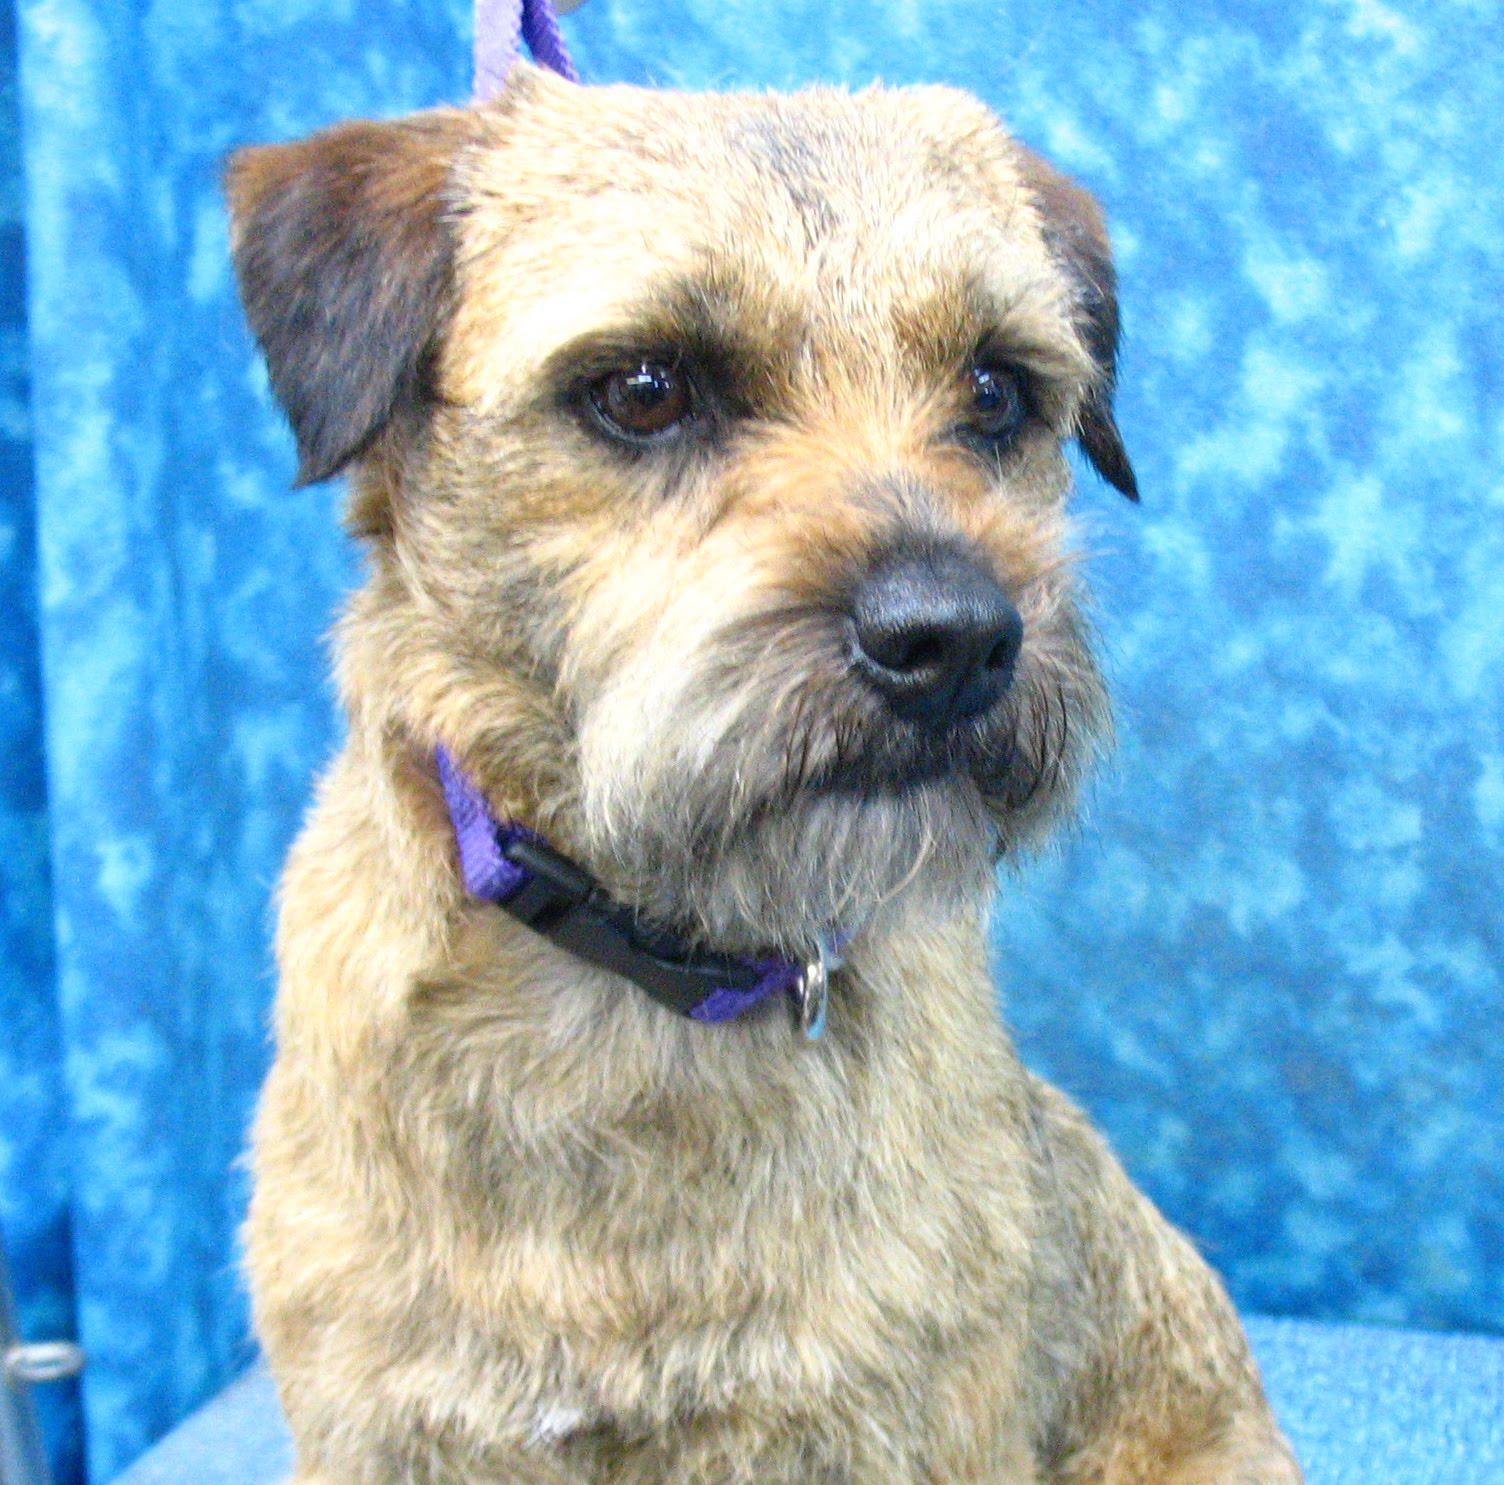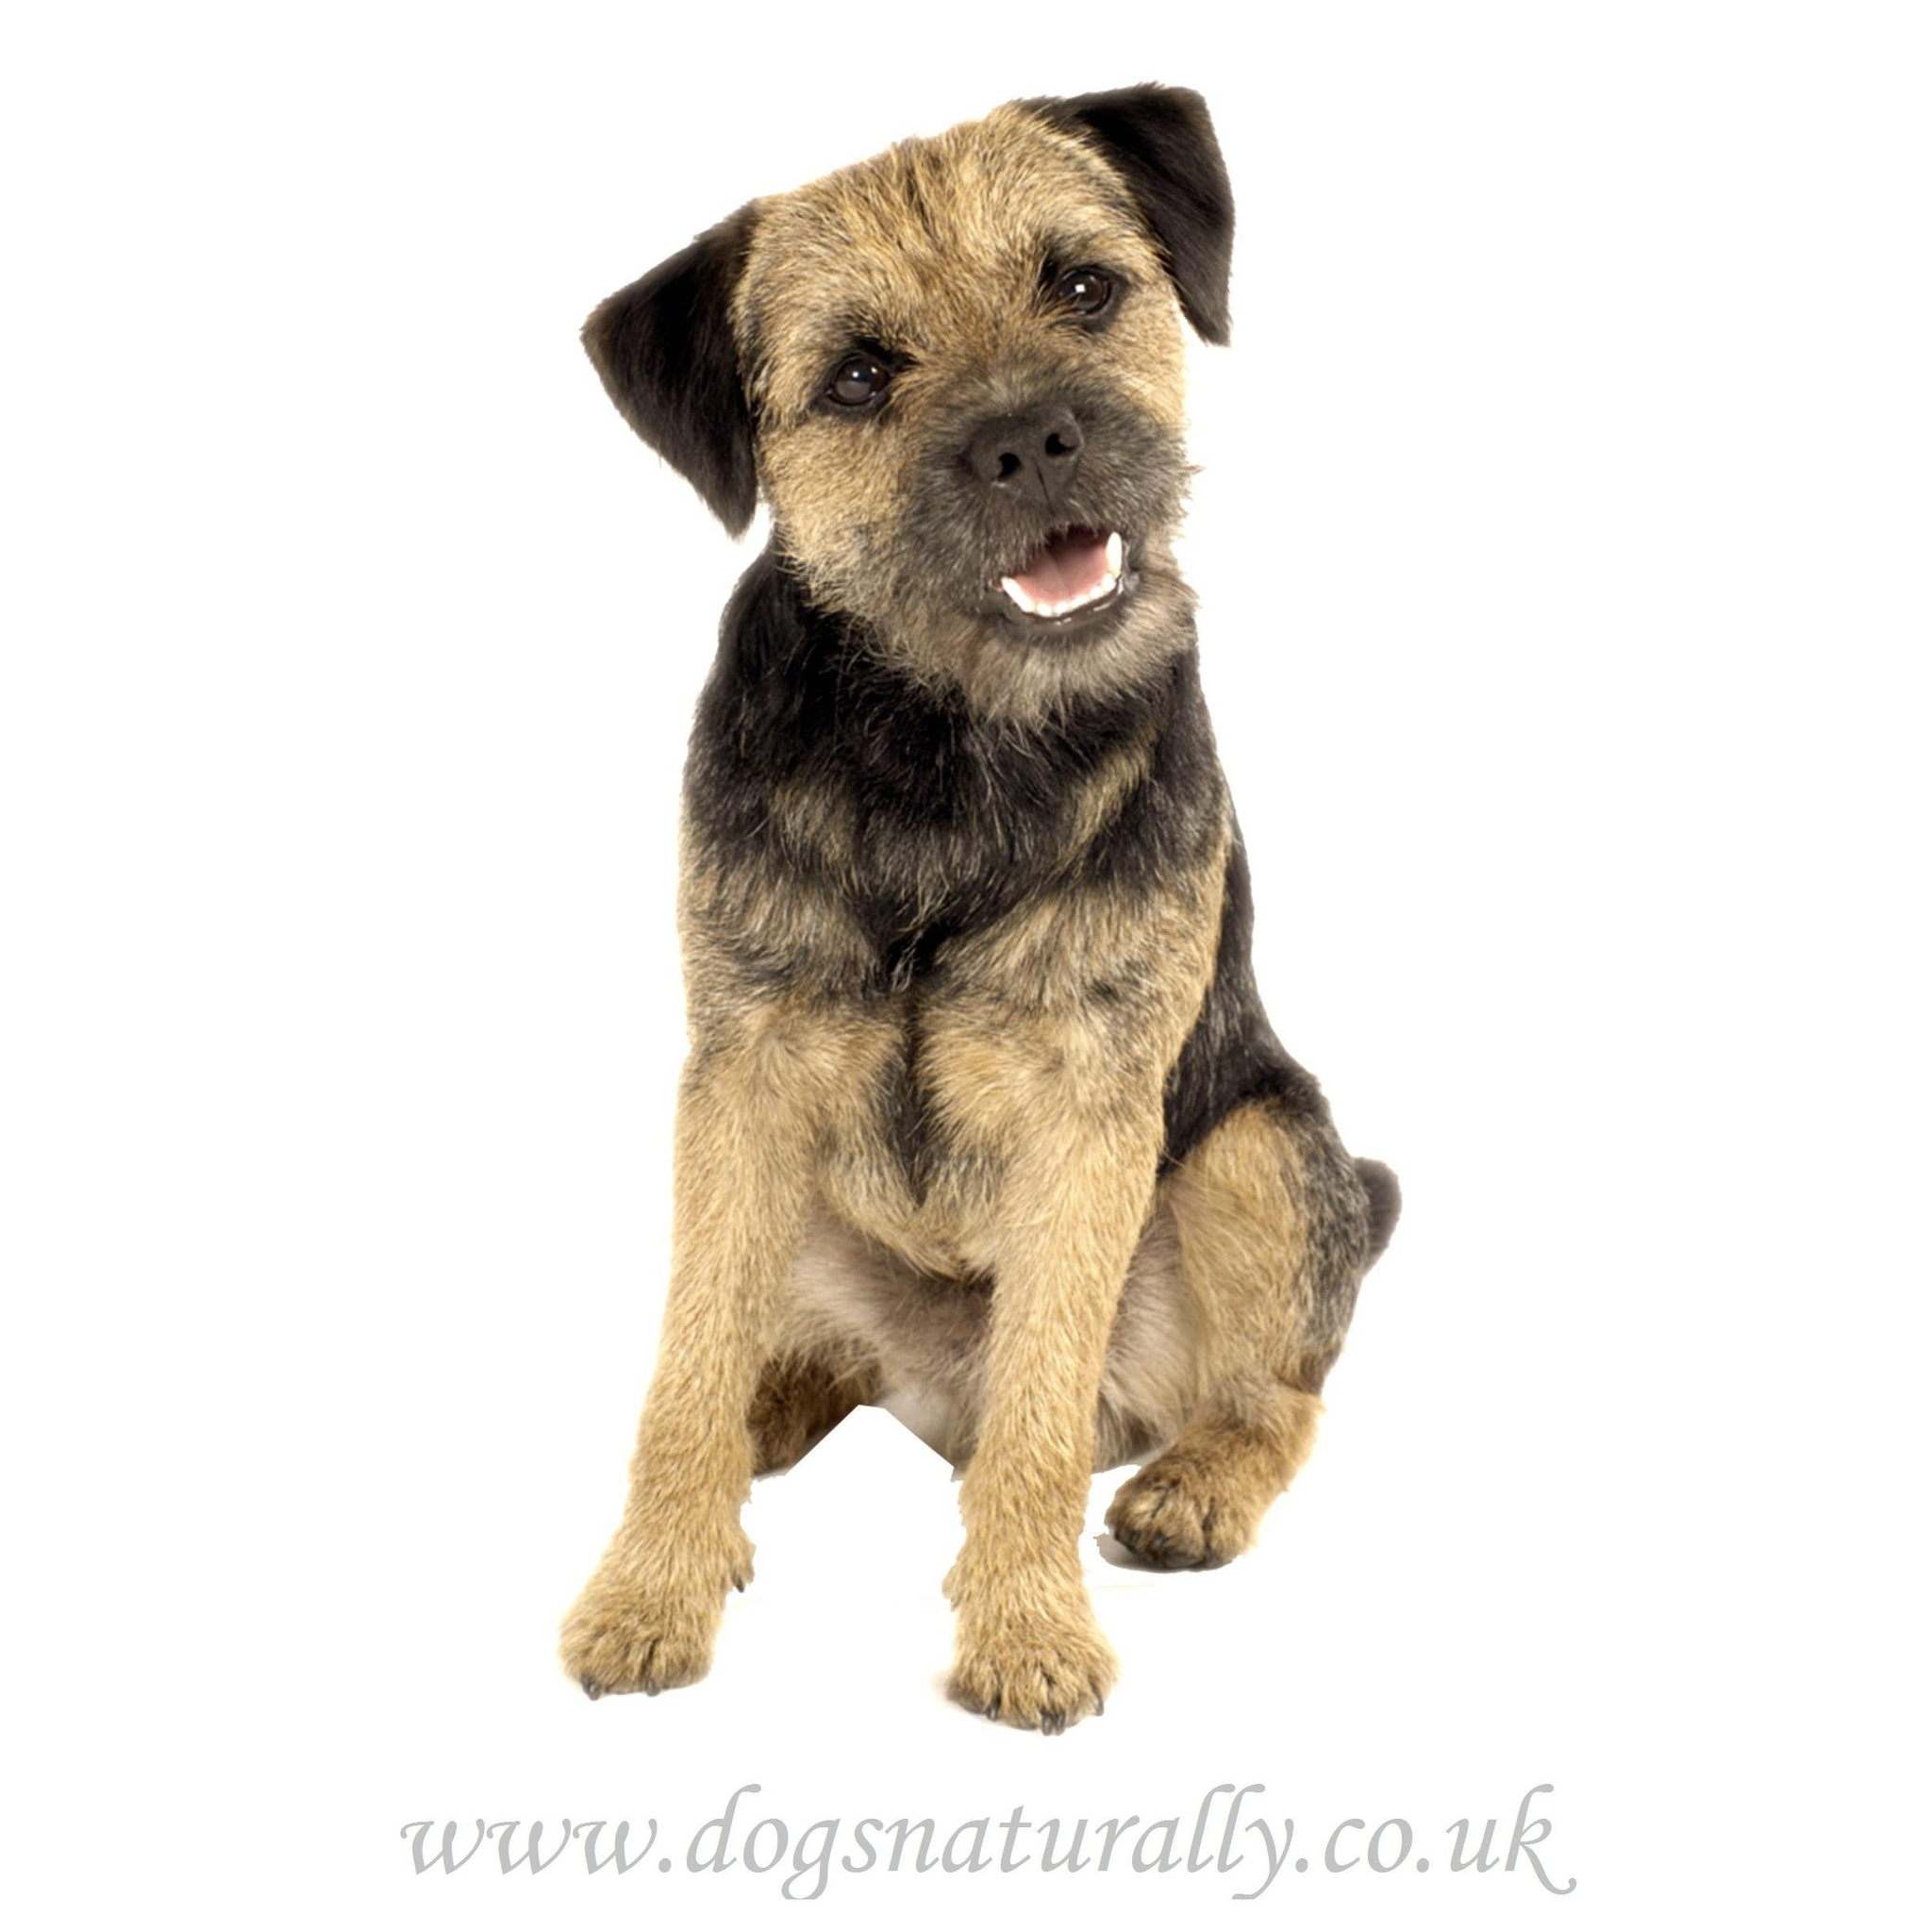The first image is the image on the left, the second image is the image on the right. For the images displayed, is the sentence "Left image shows one upright dog looking slightly downward and rightward." factually correct? Answer yes or no. Yes. The first image is the image on the left, the second image is the image on the right. Analyze the images presented: Is the assertion "A dog is wearing a collar." valid? Answer yes or no. Yes. 